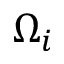<formula> <loc_0><loc_0><loc_500><loc_500>\Omega _ { i }</formula> 